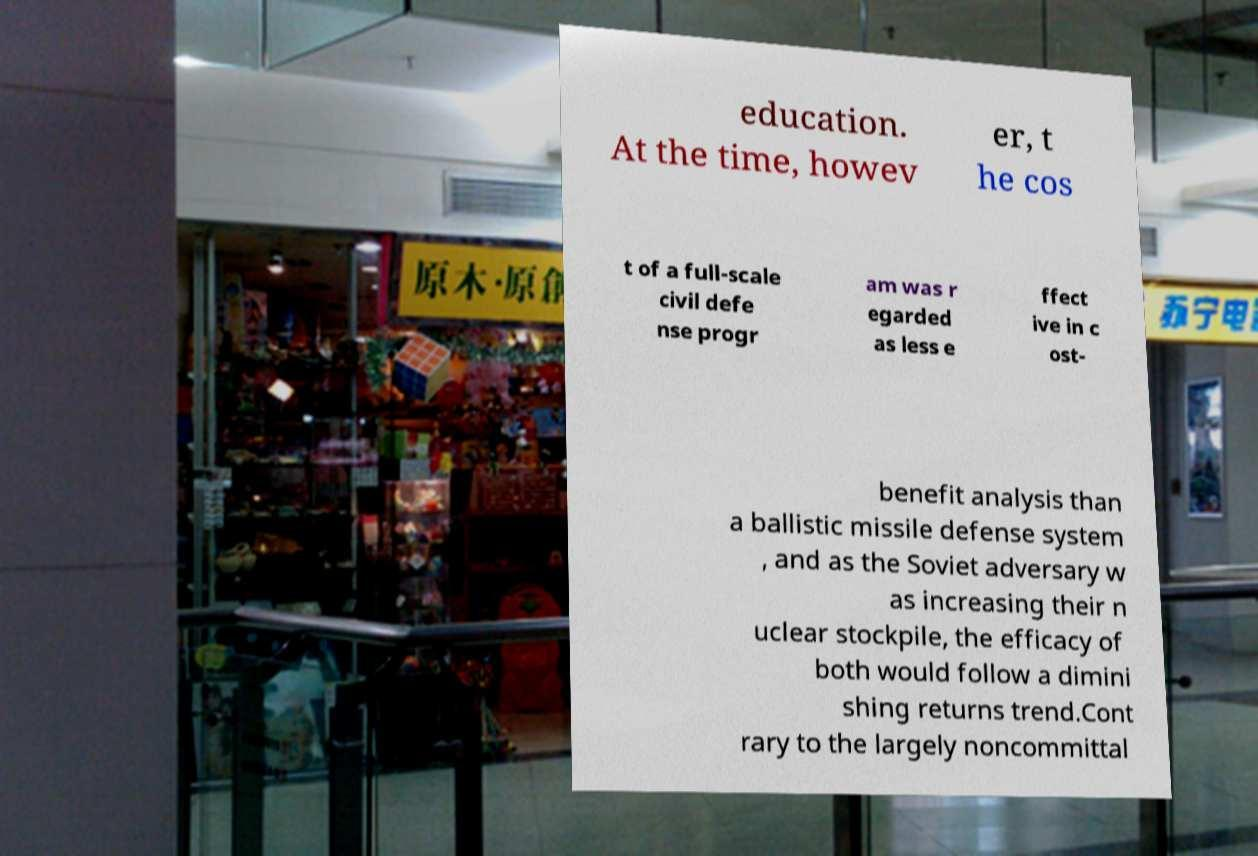There's text embedded in this image that I need extracted. Can you transcribe it verbatim? education. At the time, howev er, t he cos t of a full-scale civil defe nse progr am was r egarded as less e ffect ive in c ost- benefit analysis than a ballistic missile defense system , and as the Soviet adversary w as increasing their n uclear stockpile, the efficacy of both would follow a dimini shing returns trend.Cont rary to the largely noncommittal 